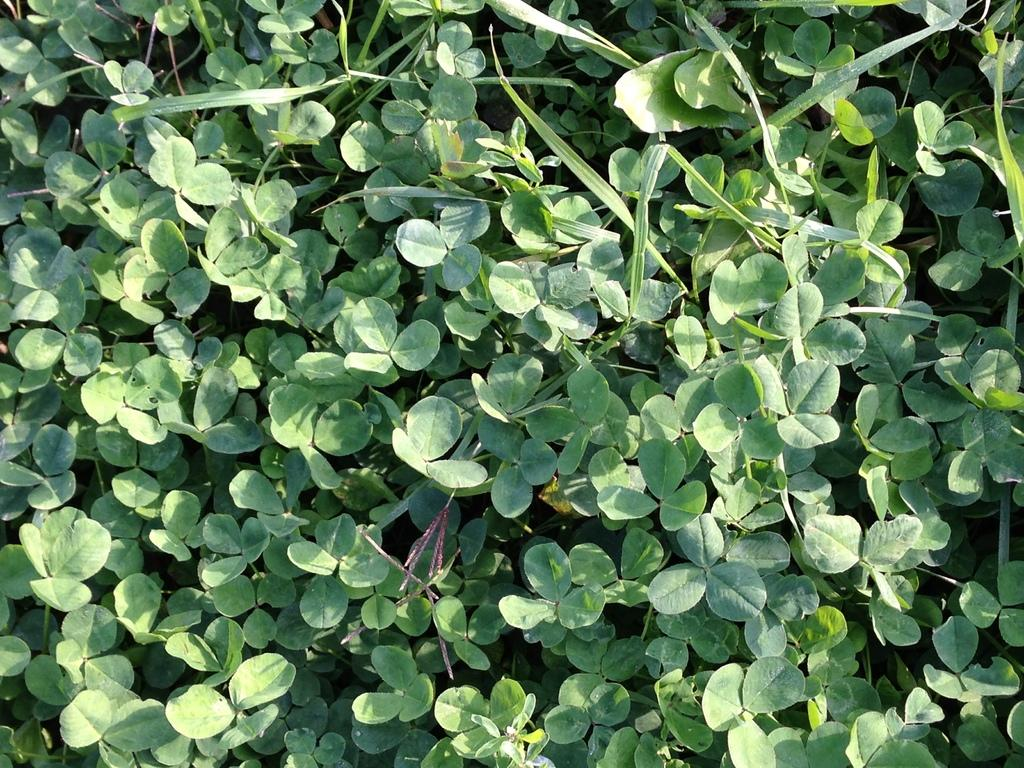What type of living organisms can be seen in the image? Plants can be seen in the image. What type of punishment is being handed down by the judge in the image? There is no judge or punishment present in the image; it only features plants. What type of engine can be seen powering the vehicle in the image? There is no vehicle or engine present in the image; it only features plants. 